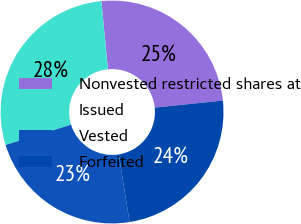Convert chart. <chart><loc_0><loc_0><loc_500><loc_500><pie_chart><fcel>Nonvested restricted shares at<fcel>Issued<fcel>Vested<fcel>Forfeited<nl><fcel>24.89%<fcel>28.25%<fcel>22.73%<fcel>24.12%<nl></chart> 